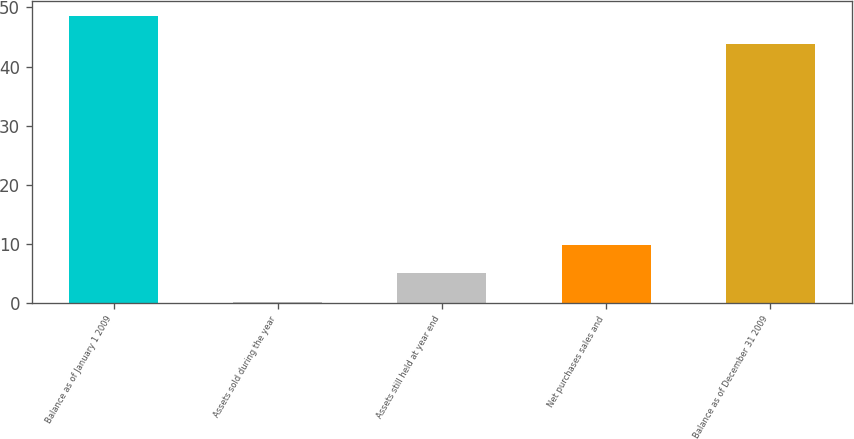Convert chart to OTSL. <chart><loc_0><loc_0><loc_500><loc_500><bar_chart><fcel>Balance as of January 1 2009<fcel>Assets sold during the year<fcel>Assets still held at year end<fcel>Net purchases sales and<fcel>Balance as of December 31 2009<nl><fcel>48.62<fcel>0.2<fcel>5.02<fcel>9.84<fcel>43.8<nl></chart> 